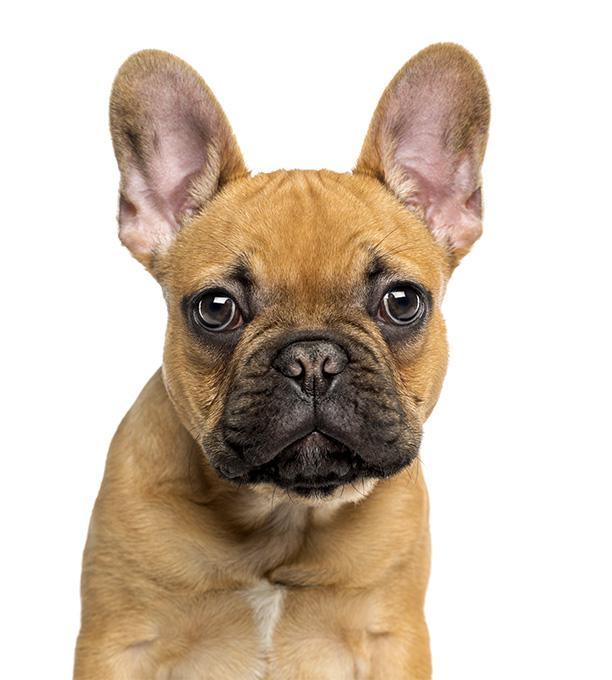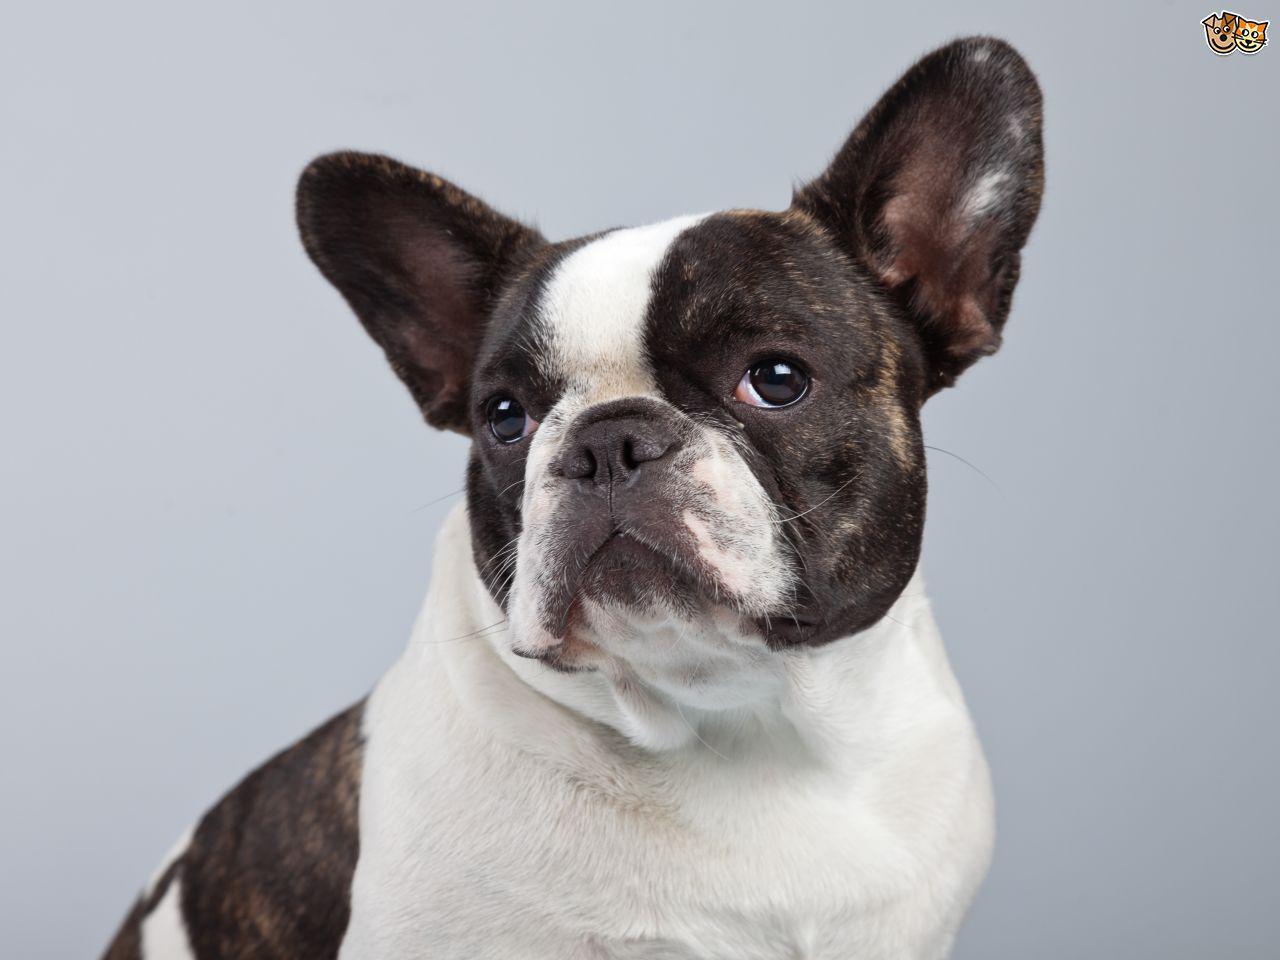The first image is the image on the left, the second image is the image on the right. For the images shown, is this caption "One tan dog and one black and white dog are shown." true? Answer yes or no. Yes. 